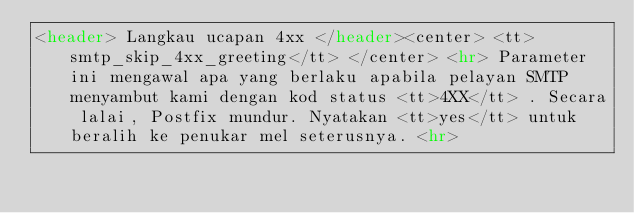Convert code to text. <code><loc_0><loc_0><loc_500><loc_500><_HTML_><header> Langkau ucapan 4xx </header><center> <tt>smtp_skip_4xx_greeting</tt> </center> <hr> Parameter ini mengawal apa yang berlaku apabila pelayan SMTP menyambut kami dengan kod status <tt>4XX</tt> . Secara lalai, Postfix mundur. Nyatakan <tt>yes</tt> untuk beralih ke penukar mel seterusnya. <hr></code> 